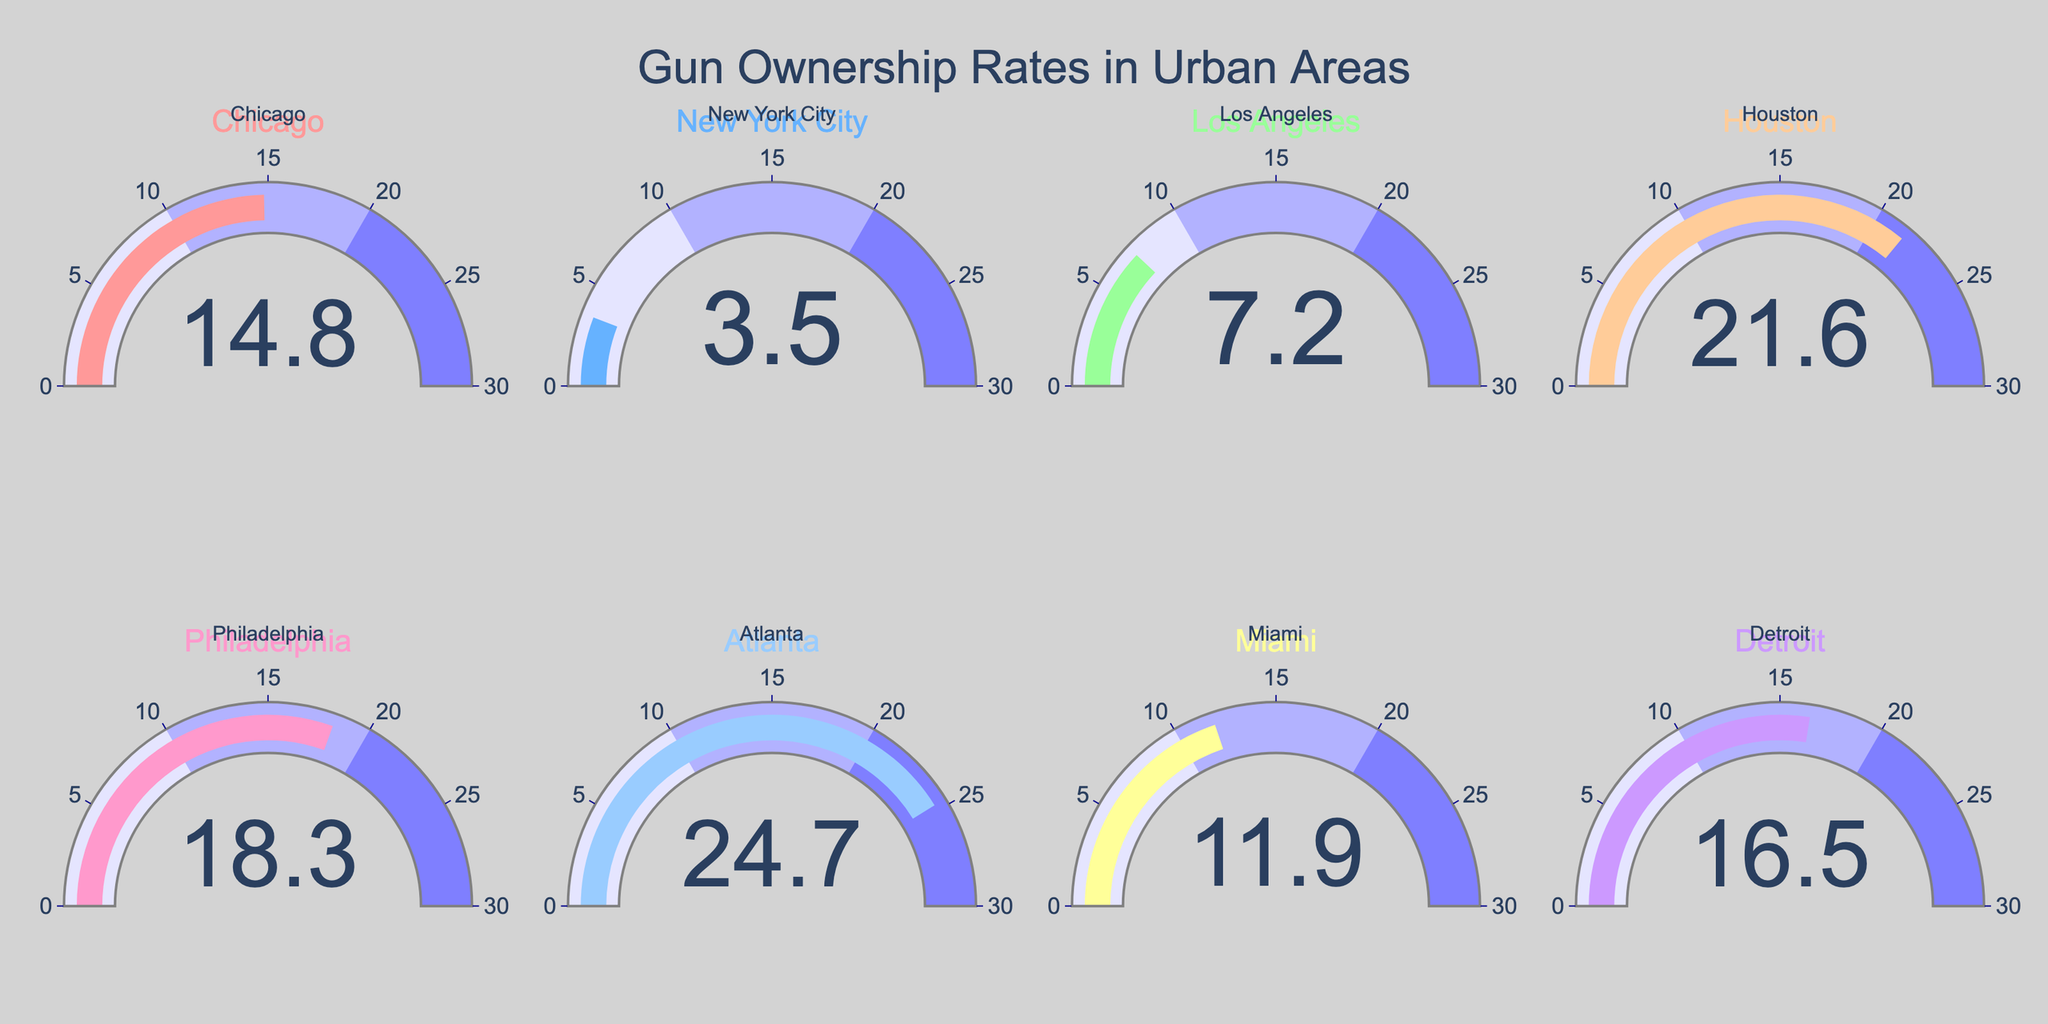What is the gun ownership rate in Chicago? The figure shows individual gauges for each city with the gun ownership rate prominently displayed. The gauge for Chicago shows a value of 14.8.
Answer: 14.8 Which city has the highest gun ownership rate? We need to compare the values on all the gauges. Atlanta has the highest value at 24.7.
Answer: Atlanta Are there any cities with a gun ownership rate lower than 5%? We need to look at all gauges and check if any value is below 5. The gauge for New York City shows 3.5, which is less than 5%.
Answer: Yes, New York City What is the combined gun ownership rate of Philadelphia and Miami? Add the values from the gauges of Philadelphia and Miami. Philadelphia is 18.3 and Miami is 11.9. The sum is 18.3 + 11.9 = 30.2.
Answer: 30.2 Which city has a higher gun ownership rate, Los Angeles or Detroit? Compare the values on the gauges for Los Angeles and Detroit. Los Angeles has 7.2 and Detroit has 16.5, so Detroit is higher.
Answer: Detroit What is the average gun ownership rate of all the cities displayed? Sum all the gun ownership rates and divide by the number of cities: (14.8 + 3.5 + 7.2 + 21.6 + 18.3 + 24.7 + 11.9 + 16.5) / 8 = 118.5 / 8 = 14.81.
Answer: 14.81 How many cities have a gun ownership rate above 15%? Check each gauge and count the ones above 15%. Chicago, Houston, Philadelphia, Atlanta, and Detroit are above 15%. There are 5 such cities.
Answer: 5 Is there any city with exactly 20% gun ownership rate? We need to examine each gauge to see if any shows exactly 20%. None of the gauges show this value.
Answer: No What is the difference in gun ownership rates between Houston and New York City? Subtract the value of New York City from Houston's value. Houston is 21.6 and New York City is 3.5. The difference is 21.6 - 3.5 = 18.1.
Answer: 18.1 